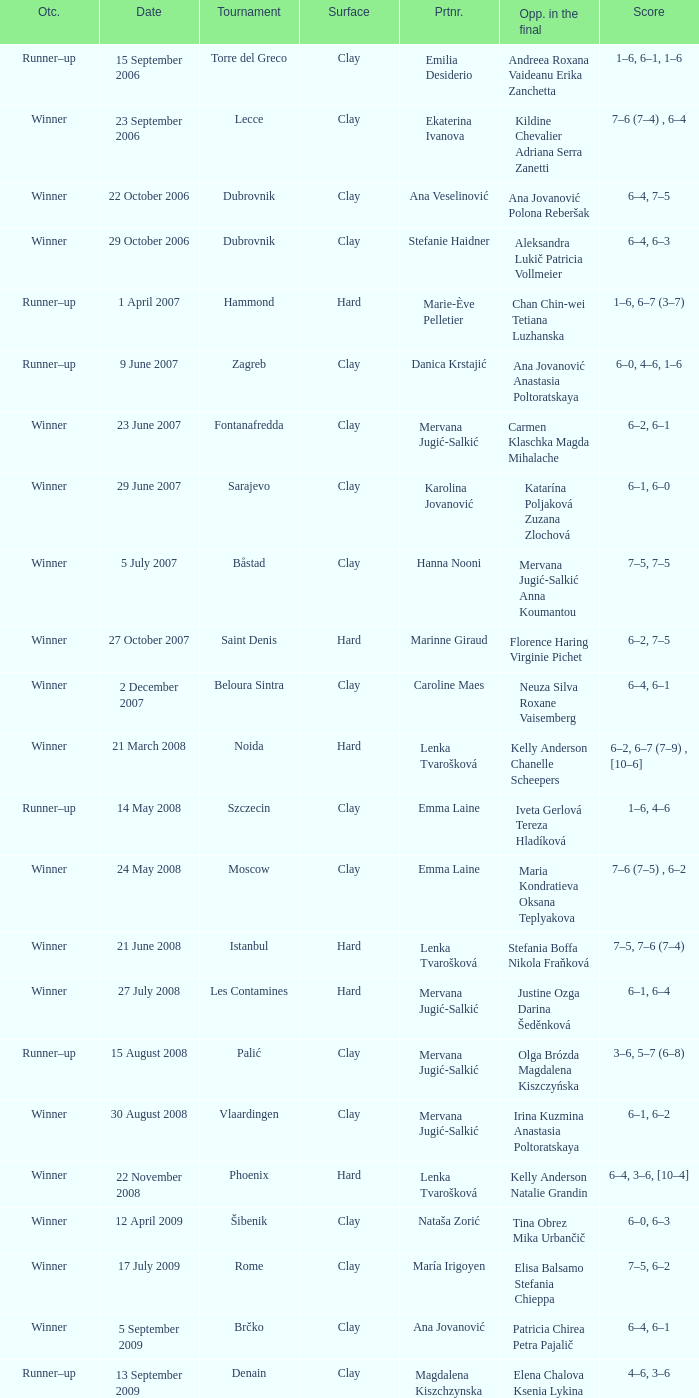Which tournament had a partner of Erika Sema? Aschaffenburg. 